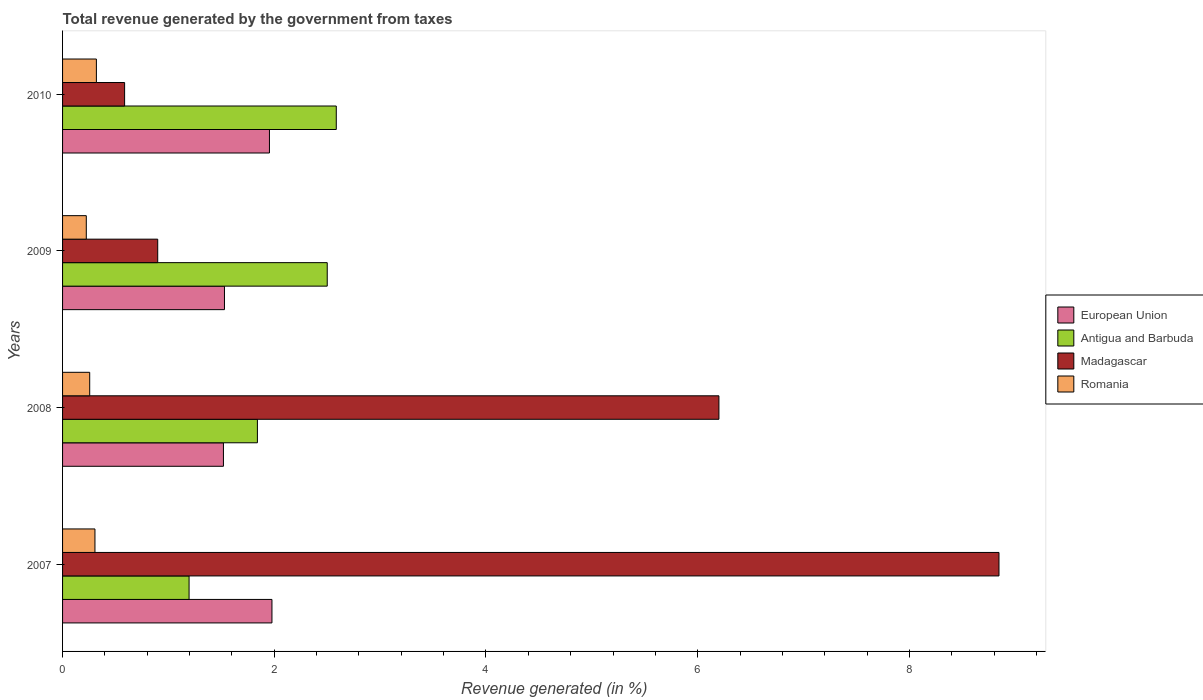In how many cases, is the number of bars for a given year not equal to the number of legend labels?
Offer a very short reply. 0. What is the total revenue generated in European Union in 2008?
Give a very brief answer. 1.52. Across all years, what is the maximum total revenue generated in European Union?
Make the answer very short. 1.98. Across all years, what is the minimum total revenue generated in Madagascar?
Provide a short and direct response. 0.59. In which year was the total revenue generated in European Union maximum?
Keep it short and to the point. 2007. In which year was the total revenue generated in Romania minimum?
Provide a short and direct response. 2009. What is the total total revenue generated in Antigua and Barbuda in the graph?
Give a very brief answer. 8.12. What is the difference between the total revenue generated in Romania in 2008 and that in 2010?
Make the answer very short. -0.06. What is the difference between the total revenue generated in Romania in 2008 and the total revenue generated in Antigua and Barbuda in 2007?
Give a very brief answer. -0.94. What is the average total revenue generated in Romania per year?
Offer a very short reply. 0.28. In the year 2009, what is the difference between the total revenue generated in Madagascar and total revenue generated in Antigua and Barbuda?
Ensure brevity in your answer.  -1.6. In how many years, is the total revenue generated in Romania greater than 8.8 %?
Your answer should be compact. 0. What is the ratio of the total revenue generated in Madagascar in 2007 to that in 2008?
Your answer should be very brief. 1.43. What is the difference between the highest and the second highest total revenue generated in Romania?
Your answer should be very brief. 0.01. What is the difference between the highest and the lowest total revenue generated in Antigua and Barbuda?
Keep it short and to the point. 1.39. In how many years, is the total revenue generated in Antigua and Barbuda greater than the average total revenue generated in Antigua and Barbuda taken over all years?
Give a very brief answer. 2. Is it the case that in every year, the sum of the total revenue generated in Antigua and Barbuda and total revenue generated in European Union is greater than the sum of total revenue generated in Romania and total revenue generated in Madagascar?
Offer a very short reply. No. What does the 2nd bar from the top in 2010 represents?
Your response must be concise. Madagascar. What does the 2nd bar from the bottom in 2007 represents?
Your answer should be compact. Antigua and Barbuda. Are all the bars in the graph horizontal?
Make the answer very short. Yes. How many years are there in the graph?
Provide a succinct answer. 4. Does the graph contain any zero values?
Your response must be concise. No. Does the graph contain grids?
Keep it short and to the point. No. How many legend labels are there?
Your answer should be very brief. 4. What is the title of the graph?
Offer a very short reply. Total revenue generated by the government from taxes. What is the label or title of the X-axis?
Give a very brief answer. Revenue generated (in %). What is the label or title of the Y-axis?
Make the answer very short. Years. What is the Revenue generated (in %) of European Union in 2007?
Give a very brief answer. 1.98. What is the Revenue generated (in %) in Antigua and Barbuda in 2007?
Ensure brevity in your answer.  1.2. What is the Revenue generated (in %) of Madagascar in 2007?
Give a very brief answer. 8.85. What is the Revenue generated (in %) of Romania in 2007?
Provide a short and direct response. 0.31. What is the Revenue generated (in %) in European Union in 2008?
Offer a very short reply. 1.52. What is the Revenue generated (in %) of Antigua and Barbuda in 2008?
Your response must be concise. 1.84. What is the Revenue generated (in %) in Madagascar in 2008?
Make the answer very short. 6.2. What is the Revenue generated (in %) of Romania in 2008?
Your answer should be very brief. 0.26. What is the Revenue generated (in %) of European Union in 2009?
Ensure brevity in your answer.  1.53. What is the Revenue generated (in %) of Antigua and Barbuda in 2009?
Keep it short and to the point. 2.5. What is the Revenue generated (in %) of Madagascar in 2009?
Give a very brief answer. 0.9. What is the Revenue generated (in %) of Romania in 2009?
Offer a very short reply. 0.22. What is the Revenue generated (in %) in European Union in 2010?
Offer a terse response. 1.95. What is the Revenue generated (in %) in Antigua and Barbuda in 2010?
Keep it short and to the point. 2.59. What is the Revenue generated (in %) in Madagascar in 2010?
Your response must be concise. 0.59. What is the Revenue generated (in %) of Romania in 2010?
Keep it short and to the point. 0.32. Across all years, what is the maximum Revenue generated (in %) in European Union?
Your answer should be very brief. 1.98. Across all years, what is the maximum Revenue generated (in %) of Antigua and Barbuda?
Your answer should be very brief. 2.59. Across all years, what is the maximum Revenue generated (in %) in Madagascar?
Your answer should be compact. 8.85. Across all years, what is the maximum Revenue generated (in %) of Romania?
Ensure brevity in your answer.  0.32. Across all years, what is the minimum Revenue generated (in %) of European Union?
Your response must be concise. 1.52. Across all years, what is the minimum Revenue generated (in %) in Antigua and Barbuda?
Your answer should be very brief. 1.2. Across all years, what is the minimum Revenue generated (in %) of Madagascar?
Ensure brevity in your answer.  0.59. Across all years, what is the minimum Revenue generated (in %) of Romania?
Your answer should be compact. 0.22. What is the total Revenue generated (in %) in European Union in the graph?
Provide a short and direct response. 6.98. What is the total Revenue generated (in %) of Antigua and Barbuda in the graph?
Give a very brief answer. 8.12. What is the total Revenue generated (in %) in Madagascar in the graph?
Offer a very short reply. 16.53. What is the total Revenue generated (in %) in Romania in the graph?
Your response must be concise. 1.11. What is the difference between the Revenue generated (in %) of European Union in 2007 and that in 2008?
Keep it short and to the point. 0.46. What is the difference between the Revenue generated (in %) in Antigua and Barbuda in 2007 and that in 2008?
Provide a succinct answer. -0.65. What is the difference between the Revenue generated (in %) of Madagascar in 2007 and that in 2008?
Offer a terse response. 2.65. What is the difference between the Revenue generated (in %) in Romania in 2007 and that in 2008?
Make the answer very short. 0.05. What is the difference between the Revenue generated (in %) in European Union in 2007 and that in 2009?
Offer a very short reply. 0.45. What is the difference between the Revenue generated (in %) of Antigua and Barbuda in 2007 and that in 2009?
Offer a very short reply. -1.31. What is the difference between the Revenue generated (in %) of Madagascar in 2007 and that in 2009?
Make the answer very short. 7.95. What is the difference between the Revenue generated (in %) in Romania in 2007 and that in 2009?
Your answer should be very brief. 0.08. What is the difference between the Revenue generated (in %) of European Union in 2007 and that in 2010?
Keep it short and to the point. 0.02. What is the difference between the Revenue generated (in %) of Antigua and Barbuda in 2007 and that in 2010?
Make the answer very short. -1.39. What is the difference between the Revenue generated (in %) of Madagascar in 2007 and that in 2010?
Make the answer very short. 8.26. What is the difference between the Revenue generated (in %) of Romania in 2007 and that in 2010?
Offer a terse response. -0.01. What is the difference between the Revenue generated (in %) of European Union in 2008 and that in 2009?
Offer a very short reply. -0.01. What is the difference between the Revenue generated (in %) in Antigua and Barbuda in 2008 and that in 2009?
Provide a succinct answer. -0.66. What is the difference between the Revenue generated (in %) of Madagascar in 2008 and that in 2009?
Ensure brevity in your answer.  5.3. What is the difference between the Revenue generated (in %) in Romania in 2008 and that in 2009?
Your answer should be very brief. 0.03. What is the difference between the Revenue generated (in %) in European Union in 2008 and that in 2010?
Your response must be concise. -0.43. What is the difference between the Revenue generated (in %) in Antigua and Barbuda in 2008 and that in 2010?
Give a very brief answer. -0.75. What is the difference between the Revenue generated (in %) in Madagascar in 2008 and that in 2010?
Offer a terse response. 5.61. What is the difference between the Revenue generated (in %) of Romania in 2008 and that in 2010?
Make the answer very short. -0.06. What is the difference between the Revenue generated (in %) in European Union in 2009 and that in 2010?
Provide a short and direct response. -0.42. What is the difference between the Revenue generated (in %) of Antigua and Barbuda in 2009 and that in 2010?
Keep it short and to the point. -0.09. What is the difference between the Revenue generated (in %) of Madagascar in 2009 and that in 2010?
Ensure brevity in your answer.  0.31. What is the difference between the Revenue generated (in %) in Romania in 2009 and that in 2010?
Your answer should be compact. -0.1. What is the difference between the Revenue generated (in %) of European Union in 2007 and the Revenue generated (in %) of Antigua and Barbuda in 2008?
Offer a very short reply. 0.14. What is the difference between the Revenue generated (in %) of European Union in 2007 and the Revenue generated (in %) of Madagascar in 2008?
Make the answer very short. -4.22. What is the difference between the Revenue generated (in %) in European Union in 2007 and the Revenue generated (in %) in Romania in 2008?
Your answer should be compact. 1.72. What is the difference between the Revenue generated (in %) of Antigua and Barbuda in 2007 and the Revenue generated (in %) of Madagascar in 2008?
Ensure brevity in your answer.  -5.01. What is the difference between the Revenue generated (in %) in Antigua and Barbuda in 2007 and the Revenue generated (in %) in Romania in 2008?
Keep it short and to the point. 0.94. What is the difference between the Revenue generated (in %) of Madagascar in 2007 and the Revenue generated (in %) of Romania in 2008?
Ensure brevity in your answer.  8.59. What is the difference between the Revenue generated (in %) of European Union in 2007 and the Revenue generated (in %) of Antigua and Barbuda in 2009?
Provide a succinct answer. -0.52. What is the difference between the Revenue generated (in %) of European Union in 2007 and the Revenue generated (in %) of Madagascar in 2009?
Give a very brief answer. 1.08. What is the difference between the Revenue generated (in %) in European Union in 2007 and the Revenue generated (in %) in Romania in 2009?
Your answer should be very brief. 1.75. What is the difference between the Revenue generated (in %) of Antigua and Barbuda in 2007 and the Revenue generated (in %) of Madagascar in 2009?
Make the answer very short. 0.3. What is the difference between the Revenue generated (in %) of Antigua and Barbuda in 2007 and the Revenue generated (in %) of Romania in 2009?
Your answer should be compact. 0.97. What is the difference between the Revenue generated (in %) in Madagascar in 2007 and the Revenue generated (in %) in Romania in 2009?
Keep it short and to the point. 8.62. What is the difference between the Revenue generated (in %) of European Union in 2007 and the Revenue generated (in %) of Antigua and Barbuda in 2010?
Provide a short and direct response. -0.61. What is the difference between the Revenue generated (in %) of European Union in 2007 and the Revenue generated (in %) of Madagascar in 2010?
Offer a terse response. 1.39. What is the difference between the Revenue generated (in %) of European Union in 2007 and the Revenue generated (in %) of Romania in 2010?
Provide a short and direct response. 1.66. What is the difference between the Revenue generated (in %) of Antigua and Barbuda in 2007 and the Revenue generated (in %) of Madagascar in 2010?
Keep it short and to the point. 0.61. What is the difference between the Revenue generated (in %) in Antigua and Barbuda in 2007 and the Revenue generated (in %) in Romania in 2010?
Ensure brevity in your answer.  0.88. What is the difference between the Revenue generated (in %) of Madagascar in 2007 and the Revenue generated (in %) of Romania in 2010?
Keep it short and to the point. 8.53. What is the difference between the Revenue generated (in %) of European Union in 2008 and the Revenue generated (in %) of Antigua and Barbuda in 2009?
Your response must be concise. -0.98. What is the difference between the Revenue generated (in %) of European Union in 2008 and the Revenue generated (in %) of Madagascar in 2009?
Your answer should be compact. 0.62. What is the difference between the Revenue generated (in %) of European Union in 2008 and the Revenue generated (in %) of Romania in 2009?
Your answer should be very brief. 1.3. What is the difference between the Revenue generated (in %) of Antigua and Barbuda in 2008 and the Revenue generated (in %) of Madagascar in 2009?
Offer a very short reply. 0.94. What is the difference between the Revenue generated (in %) in Antigua and Barbuda in 2008 and the Revenue generated (in %) in Romania in 2009?
Offer a very short reply. 1.62. What is the difference between the Revenue generated (in %) of Madagascar in 2008 and the Revenue generated (in %) of Romania in 2009?
Provide a succinct answer. 5.98. What is the difference between the Revenue generated (in %) in European Union in 2008 and the Revenue generated (in %) in Antigua and Barbuda in 2010?
Your response must be concise. -1.07. What is the difference between the Revenue generated (in %) in European Union in 2008 and the Revenue generated (in %) in Madagascar in 2010?
Your answer should be very brief. 0.93. What is the difference between the Revenue generated (in %) of European Union in 2008 and the Revenue generated (in %) of Romania in 2010?
Provide a succinct answer. 1.2. What is the difference between the Revenue generated (in %) of Antigua and Barbuda in 2008 and the Revenue generated (in %) of Madagascar in 2010?
Your answer should be compact. 1.25. What is the difference between the Revenue generated (in %) in Antigua and Barbuda in 2008 and the Revenue generated (in %) in Romania in 2010?
Ensure brevity in your answer.  1.52. What is the difference between the Revenue generated (in %) of Madagascar in 2008 and the Revenue generated (in %) of Romania in 2010?
Ensure brevity in your answer.  5.88. What is the difference between the Revenue generated (in %) of European Union in 2009 and the Revenue generated (in %) of Antigua and Barbuda in 2010?
Your answer should be compact. -1.06. What is the difference between the Revenue generated (in %) in European Union in 2009 and the Revenue generated (in %) in Madagascar in 2010?
Ensure brevity in your answer.  0.94. What is the difference between the Revenue generated (in %) in European Union in 2009 and the Revenue generated (in %) in Romania in 2010?
Provide a succinct answer. 1.21. What is the difference between the Revenue generated (in %) of Antigua and Barbuda in 2009 and the Revenue generated (in %) of Madagascar in 2010?
Provide a succinct answer. 1.91. What is the difference between the Revenue generated (in %) in Antigua and Barbuda in 2009 and the Revenue generated (in %) in Romania in 2010?
Make the answer very short. 2.18. What is the difference between the Revenue generated (in %) of Madagascar in 2009 and the Revenue generated (in %) of Romania in 2010?
Give a very brief answer. 0.58. What is the average Revenue generated (in %) in European Union per year?
Offer a terse response. 1.75. What is the average Revenue generated (in %) in Antigua and Barbuda per year?
Provide a short and direct response. 2.03. What is the average Revenue generated (in %) in Madagascar per year?
Keep it short and to the point. 4.13. What is the average Revenue generated (in %) in Romania per year?
Make the answer very short. 0.28. In the year 2007, what is the difference between the Revenue generated (in %) in European Union and Revenue generated (in %) in Antigua and Barbuda?
Your answer should be compact. 0.78. In the year 2007, what is the difference between the Revenue generated (in %) in European Union and Revenue generated (in %) in Madagascar?
Your answer should be compact. -6.87. In the year 2007, what is the difference between the Revenue generated (in %) in European Union and Revenue generated (in %) in Romania?
Give a very brief answer. 1.67. In the year 2007, what is the difference between the Revenue generated (in %) in Antigua and Barbuda and Revenue generated (in %) in Madagascar?
Your response must be concise. -7.65. In the year 2007, what is the difference between the Revenue generated (in %) of Antigua and Barbuda and Revenue generated (in %) of Romania?
Keep it short and to the point. 0.89. In the year 2007, what is the difference between the Revenue generated (in %) of Madagascar and Revenue generated (in %) of Romania?
Keep it short and to the point. 8.54. In the year 2008, what is the difference between the Revenue generated (in %) in European Union and Revenue generated (in %) in Antigua and Barbuda?
Provide a succinct answer. -0.32. In the year 2008, what is the difference between the Revenue generated (in %) of European Union and Revenue generated (in %) of Madagascar?
Your answer should be very brief. -4.68. In the year 2008, what is the difference between the Revenue generated (in %) in European Union and Revenue generated (in %) in Romania?
Ensure brevity in your answer.  1.26. In the year 2008, what is the difference between the Revenue generated (in %) in Antigua and Barbuda and Revenue generated (in %) in Madagascar?
Provide a succinct answer. -4.36. In the year 2008, what is the difference between the Revenue generated (in %) in Antigua and Barbuda and Revenue generated (in %) in Romania?
Keep it short and to the point. 1.58. In the year 2008, what is the difference between the Revenue generated (in %) of Madagascar and Revenue generated (in %) of Romania?
Give a very brief answer. 5.94. In the year 2009, what is the difference between the Revenue generated (in %) of European Union and Revenue generated (in %) of Antigua and Barbuda?
Make the answer very short. -0.97. In the year 2009, what is the difference between the Revenue generated (in %) in European Union and Revenue generated (in %) in Madagascar?
Keep it short and to the point. 0.63. In the year 2009, what is the difference between the Revenue generated (in %) of European Union and Revenue generated (in %) of Romania?
Your response must be concise. 1.31. In the year 2009, what is the difference between the Revenue generated (in %) in Antigua and Barbuda and Revenue generated (in %) in Madagascar?
Provide a succinct answer. 1.6. In the year 2009, what is the difference between the Revenue generated (in %) in Antigua and Barbuda and Revenue generated (in %) in Romania?
Provide a succinct answer. 2.28. In the year 2009, what is the difference between the Revenue generated (in %) in Madagascar and Revenue generated (in %) in Romania?
Offer a very short reply. 0.67. In the year 2010, what is the difference between the Revenue generated (in %) of European Union and Revenue generated (in %) of Antigua and Barbuda?
Make the answer very short. -0.63. In the year 2010, what is the difference between the Revenue generated (in %) of European Union and Revenue generated (in %) of Madagascar?
Your response must be concise. 1.37. In the year 2010, what is the difference between the Revenue generated (in %) of European Union and Revenue generated (in %) of Romania?
Provide a short and direct response. 1.64. In the year 2010, what is the difference between the Revenue generated (in %) in Antigua and Barbuda and Revenue generated (in %) in Madagascar?
Provide a short and direct response. 2. In the year 2010, what is the difference between the Revenue generated (in %) of Antigua and Barbuda and Revenue generated (in %) of Romania?
Your answer should be compact. 2.27. In the year 2010, what is the difference between the Revenue generated (in %) of Madagascar and Revenue generated (in %) of Romania?
Your answer should be compact. 0.27. What is the ratio of the Revenue generated (in %) of European Union in 2007 to that in 2008?
Offer a very short reply. 1.3. What is the ratio of the Revenue generated (in %) in Antigua and Barbuda in 2007 to that in 2008?
Provide a succinct answer. 0.65. What is the ratio of the Revenue generated (in %) in Madagascar in 2007 to that in 2008?
Ensure brevity in your answer.  1.43. What is the ratio of the Revenue generated (in %) of Romania in 2007 to that in 2008?
Provide a short and direct response. 1.19. What is the ratio of the Revenue generated (in %) of European Union in 2007 to that in 2009?
Your answer should be very brief. 1.29. What is the ratio of the Revenue generated (in %) in Antigua and Barbuda in 2007 to that in 2009?
Your answer should be compact. 0.48. What is the ratio of the Revenue generated (in %) in Madagascar in 2007 to that in 2009?
Provide a short and direct response. 9.84. What is the ratio of the Revenue generated (in %) of Romania in 2007 to that in 2009?
Provide a short and direct response. 1.36. What is the ratio of the Revenue generated (in %) in European Union in 2007 to that in 2010?
Offer a very short reply. 1.01. What is the ratio of the Revenue generated (in %) of Antigua and Barbuda in 2007 to that in 2010?
Keep it short and to the point. 0.46. What is the ratio of the Revenue generated (in %) of Madagascar in 2007 to that in 2010?
Your answer should be very brief. 15.09. What is the ratio of the Revenue generated (in %) in Romania in 2007 to that in 2010?
Give a very brief answer. 0.96. What is the ratio of the Revenue generated (in %) in European Union in 2008 to that in 2009?
Make the answer very short. 0.99. What is the ratio of the Revenue generated (in %) in Antigua and Barbuda in 2008 to that in 2009?
Provide a succinct answer. 0.74. What is the ratio of the Revenue generated (in %) of Madagascar in 2008 to that in 2009?
Your answer should be compact. 6.9. What is the ratio of the Revenue generated (in %) in Romania in 2008 to that in 2009?
Make the answer very short. 1.14. What is the ratio of the Revenue generated (in %) of European Union in 2008 to that in 2010?
Offer a terse response. 0.78. What is the ratio of the Revenue generated (in %) in Antigua and Barbuda in 2008 to that in 2010?
Ensure brevity in your answer.  0.71. What is the ratio of the Revenue generated (in %) of Madagascar in 2008 to that in 2010?
Ensure brevity in your answer.  10.58. What is the ratio of the Revenue generated (in %) of Romania in 2008 to that in 2010?
Ensure brevity in your answer.  0.8. What is the ratio of the Revenue generated (in %) in European Union in 2009 to that in 2010?
Your answer should be very brief. 0.78. What is the ratio of the Revenue generated (in %) of Antigua and Barbuda in 2009 to that in 2010?
Offer a terse response. 0.97. What is the ratio of the Revenue generated (in %) of Madagascar in 2009 to that in 2010?
Ensure brevity in your answer.  1.53. What is the ratio of the Revenue generated (in %) of Romania in 2009 to that in 2010?
Provide a short and direct response. 0.7. What is the difference between the highest and the second highest Revenue generated (in %) of European Union?
Provide a short and direct response. 0.02. What is the difference between the highest and the second highest Revenue generated (in %) in Antigua and Barbuda?
Give a very brief answer. 0.09. What is the difference between the highest and the second highest Revenue generated (in %) in Madagascar?
Keep it short and to the point. 2.65. What is the difference between the highest and the second highest Revenue generated (in %) in Romania?
Provide a short and direct response. 0.01. What is the difference between the highest and the lowest Revenue generated (in %) of European Union?
Give a very brief answer. 0.46. What is the difference between the highest and the lowest Revenue generated (in %) in Antigua and Barbuda?
Offer a very short reply. 1.39. What is the difference between the highest and the lowest Revenue generated (in %) of Madagascar?
Your answer should be compact. 8.26. What is the difference between the highest and the lowest Revenue generated (in %) in Romania?
Your answer should be compact. 0.1. 